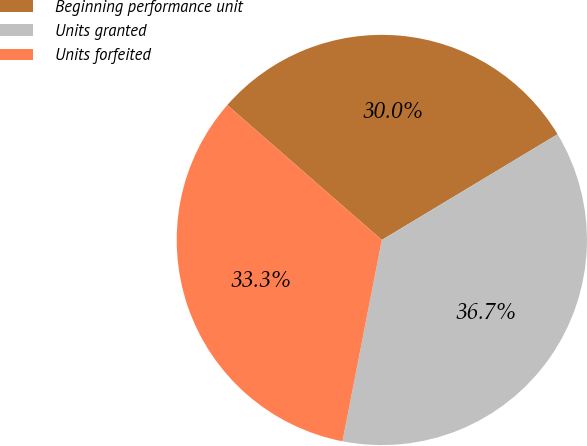Convert chart to OTSL. <chart><loc_0><loc_0><loc_500><loc_500><pie_chart><fcel>Beginning performance unit<fcel>Units granted<fcel>Units forfeited<nl><fcel>29.96%<fcel>36.69%<fcel>33.35%<nl></chart> 